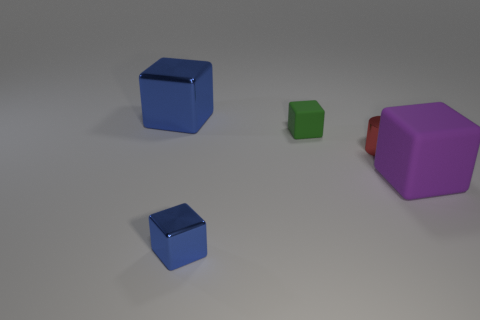What color is the cube that is the same size as the purple matte object?
Make the answer very short. Blue. What number of big objects are brown shiny blocks or green matte things?
Your response must be concise. 0. There is a thing that is both behind the large purple matte thing and to the right of the small green rubber cube; what is its material?
Your answer should be very brief. Metal. There is a blue object that is in front of the tiny cylinder; does it have the same shape as the tiny thing right of the small green cube?
Provide a succinct answer. No. What shape is the small shiny thing that is the same color as the big metallic block?
Your response must be concise. Cube. How many things are red metal things that are left of the large matte thing or blue metallic blocks?
Make the answer very short. 3. Do the red shiny cylinder and the green object have the same size?
Give a very brief answer. Yes. What color is the metallic block that is behind the small metallic block?
Your answer should be very brief. Blue. What is the size of the object that is the same material as the green block?
Your answer should be compact. Large. Does the purple rubber thing have the same size as the blue metallic block that is right of the big metal thing?
Make the answer very short. No. 